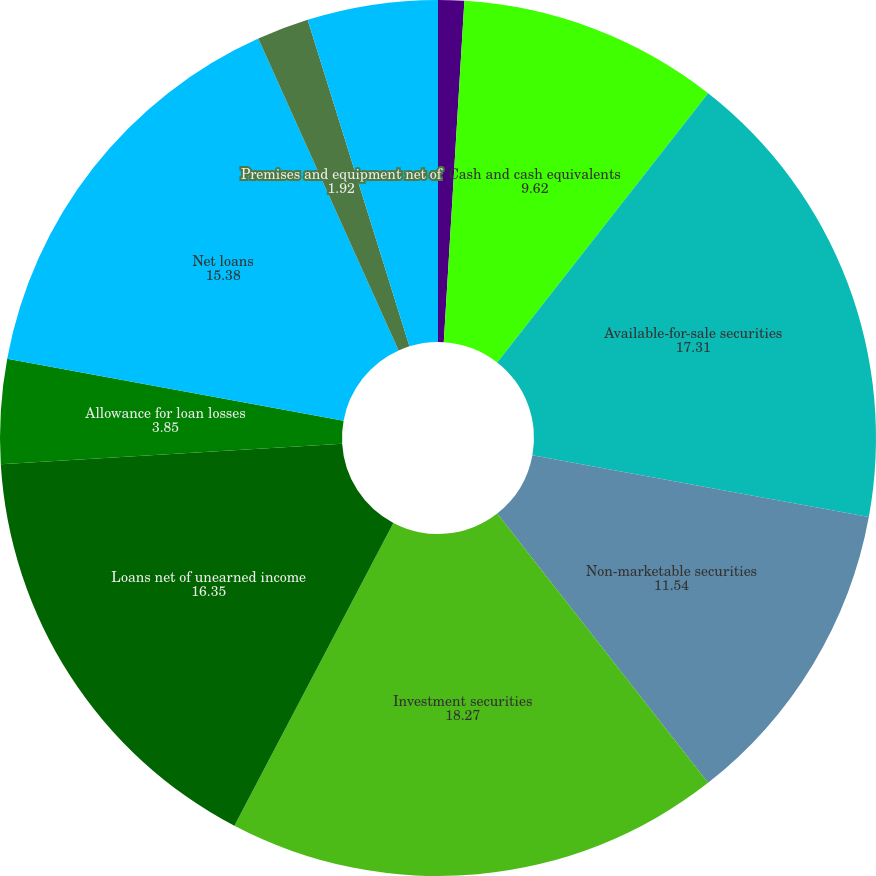Convert chart to OTSL. <chart><loc_0><loc_0><loc_500><loc_500><pie_chart><fcel>(Dollars in thousands except<fcel>Cash and cash equivalents<fcel>Available-for-sale securities<fcel>Non-marketable securities<fcel>Investment securities<fcel>Loans net of unearned income<fcel>Allowance for loan losses<fcel>Net loans<fcel>Premises and equipment net of<fcel>Accrued interest receivable<nl><fcel>0.96%<fcel>9.62%<fcel>17.31%<fcel>11.54%<fcel>18.27%<fcel>16.35%<fcel>3.85%<fcel>15.38%<fcel>1.92%<fcel>4.81%<nl></chart> 